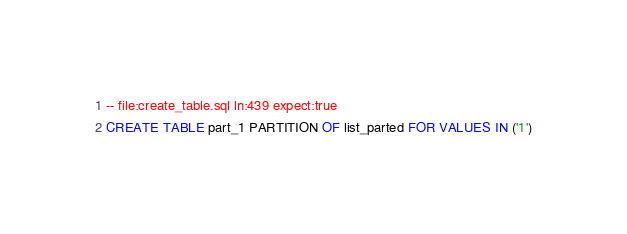Convert code to text. <code><loc_0><loc_0><loc_500><loc_500><_SQL_>-- file:create_table.sql ln:439 expect:true
CREATE TABLE part_1 PARTITION OF list_parted FOR VALUES IN ('1')
</code> 